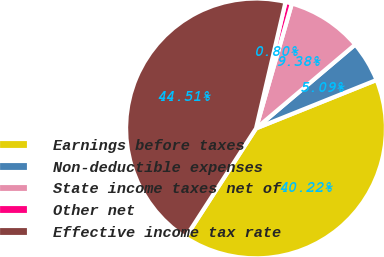<chart> <loc_0><loc_0><loc_500><loc_500><pie_chart><fcel>Earnings before taxes<fcel>Non-deductible expenses<fcel>State income taxes net of<fcel>Other net<fcel>Effective income tax rate<nl><fcel>40.22%<fcel>5.09%<fcel>9.38%<fcel>0.8%<fcel>44.51%<nl></chart> 